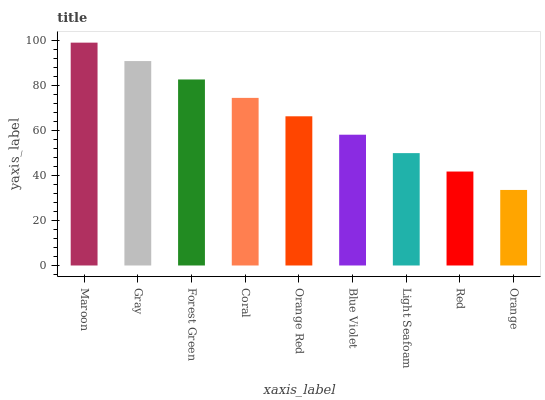Is Orange the minimum?
Answer yes or no. Yes. Is Maroon the maximum?
Answer yes or no. Yes. Is Gray the minimum?
Answer yes or no. No. Is Gray the maximum?
Answer yes or no. No. Is Maroon greater than Gray?
Answer yes or no. Yes. Is Gray less than Maroon?
Answer yes or no. Yes. Is Gray greater than Maroon?
Answer yes or no. No. Is Maroon less than Gray?
Answer yes or no. No. Is Orange Red the high median?
Answer yes or no. Yes. Is Orange Red the low median?
Answer yes or no. Yes. Is Maroon the high median?
Answer yes or no. No. Is Light Seafoam the low median?
Answer yes or no. No. 